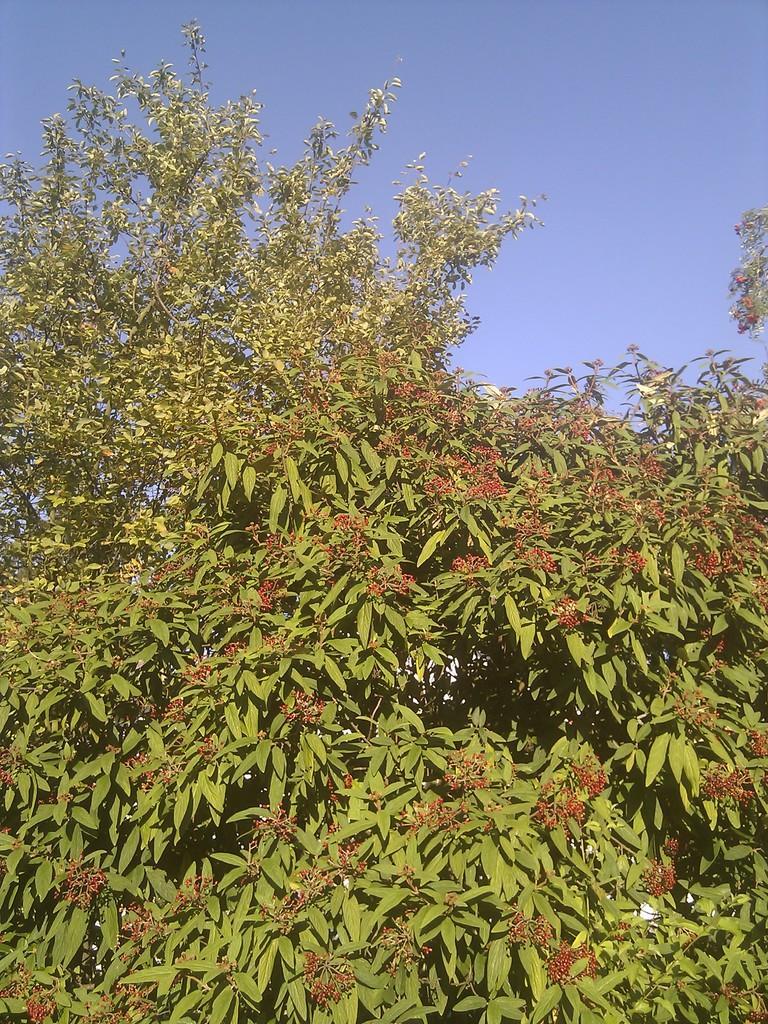Could you give a brief overview of what you see in this image? In this image I can see some trees, at the top of the image I can see the sky. 